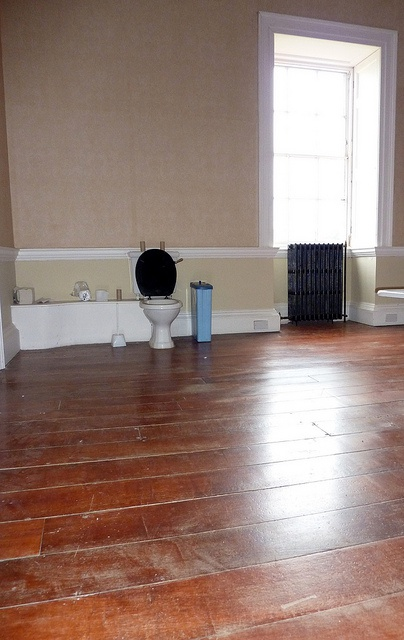Describe the objects in this image and their specific colors. I can see a toilet in maroon, black, darkgray, and gray tones in this image. 